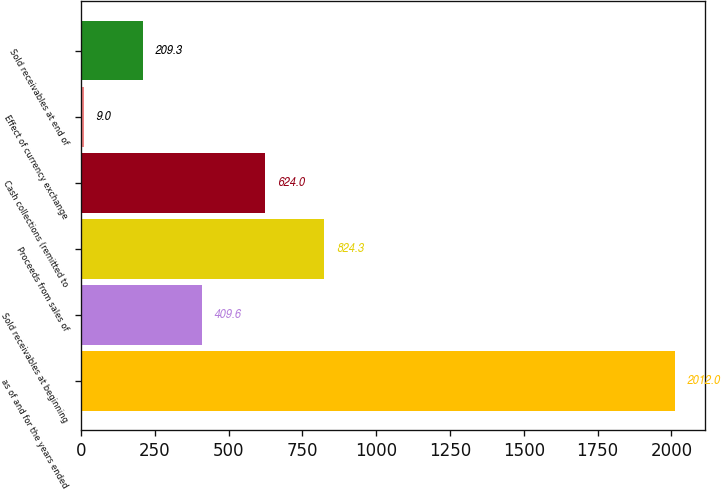<chart> <loc_0><loc_0><loc_500><loc_500><bar_chart><fcel>as of and for the years ended<fcel>Sold receivables at beginning<fcel>Proceeds from sales of<fcel>Cash collections (remitted to<fcel>Effect of currency exchange<fcel>Sold receivables at end of<nl><fcel>2012<fcel>409.6<fcel>824.3<fcel>624<fcel>9<fcel>209.3<nl></chart> 